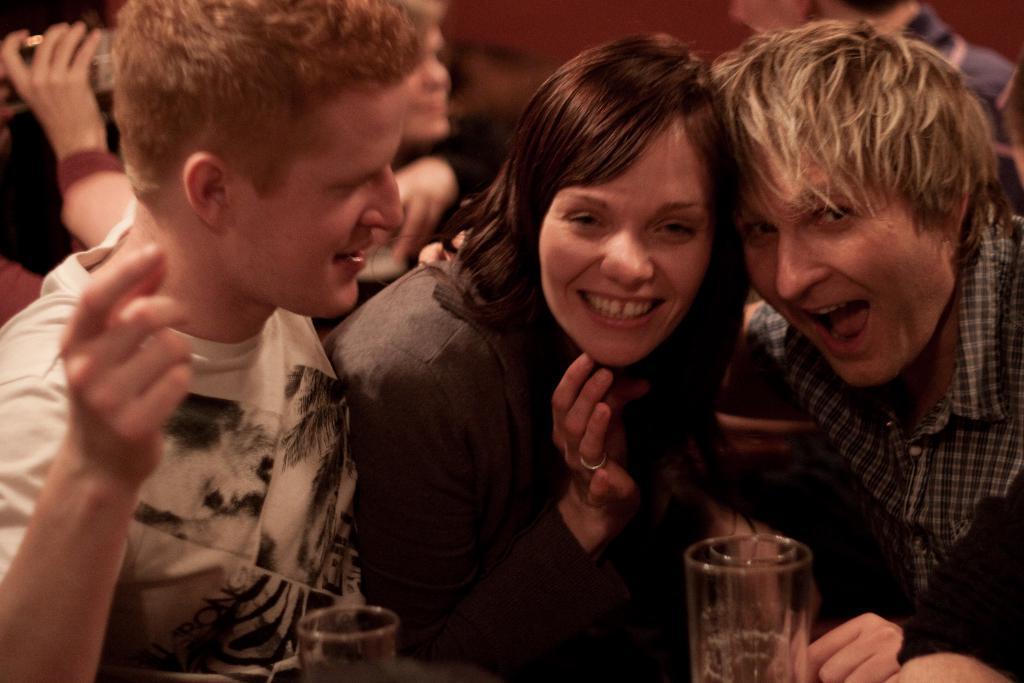In one or two sentences, can you explain what this image depicts? This picture shows few men and a woman and we see smile on their faces and we see couple of glasses. 